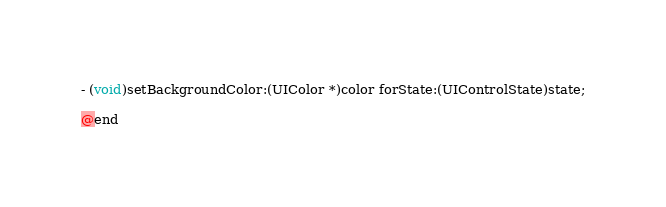Convert code to text. <code><loc_0><loc_0><loc_500><loc_500><_C_>
- (void)setBackgroundColor:(UIColor *)color forState:(UIControlState)state;

@end</code> 